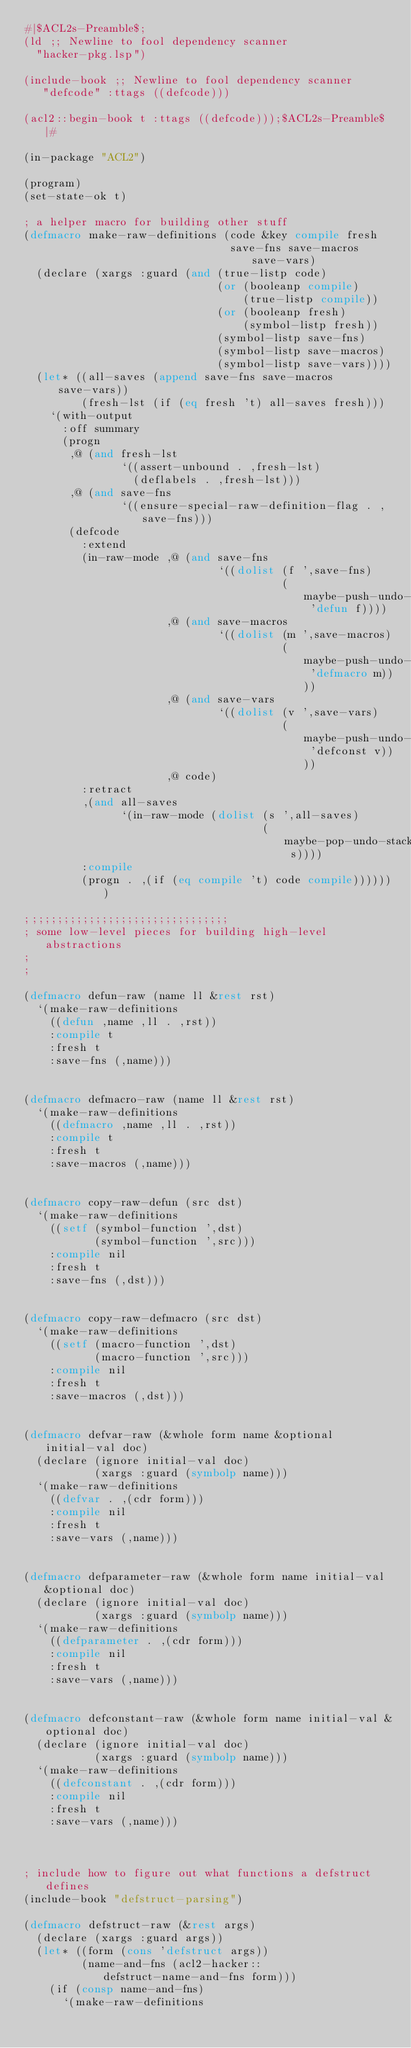<code> <loc_0><loc_0><loc_500><loc_500><_Lisp_>#|$ACL2s-Preamble$;
(ld ;; Newline to fool dependency scanner
  "hacker-pkg.lsp")

(include-book ;; Newline to fool dependency scanner
   "defcode" :ttags ((defcode)))

(acl2::begin-book t :ttags ((defcode)));$ACL2s-Preamble$|#

(in-package "ACL2")

(program)
(set-state-ok t)

; a helper macro for building other stuff
(defmacro make-raw-definitions (code &key compile fresh
                                save-fns save-macros save-vars)
  (declare (xargs :guard (and (true-listp code)
                              (or (booleanp compile)
                                  (true-listp compile))
                              (or (booleanp fresh)
                                  (symbol-listp fresh))
                              (symbol-listp save-fns)
                              (symbol-listp save-macros)
                              (symbol-listp save-vars))))
  (let* ((all-saves (append save-fns save-macros save-vars))
         (fresh-lst (if (eq fresh 't) all-saves fresh)))
    `(with-output
      :off summary
      (progn
       ,@ (and fresh-lst
               `((assert-unbound . ,fresh-lst)
                 (deflabels . ,fresh-lst)))
       ,@ (and save-fns
               `((ensure-special-raw-definition-flag . ,save-fns)))
       (defcode
         :extend
         (in-raw-mode ,@ (and save-fns
                              `((dolist (f ',save-fns)
                                        (maybe-push-undo-stack 'defun f))))
                      ,@ (and save-macros
                              `((dolist (m ',save-macros)
                                        (maybe-push-undo-stack 'defmacro m))))
                      ,@ (and save-vars
                              `((dolist (v ',save-vars)
                                        (maybe-push-undo-stack 'defconst v))))
                      ,@ code)
         :retract
         ,(and all-saves
               `(in-raw-mode (dolist (s ',all-saves)
                                     (maybe-pop-undo-stack s))))
         :compile
         (progn . ,(if (eq compile 't) code compile)))))))

;;;;;;;;;;;;;;;;;;;;;;;;;;;;;;;;
; some low-level pieces for building high-level abstractions
;
;

(defmacro defun-raw (name ll &rest rst)
  `(make-raw-definitions
    ((defun ,name ,ll . ,rst))
    :compile t
    :fresh t
    :save-fns (,name)))


(defmacro defmacro-raw (name ll &rest rst)
  `(make-raw-definitions
    ((defmacro ,name ,ll . ,rst))
    :compile t
    :fresh t
    :save-macros (,name)))


(defmacro copy-raw-defun (src dst)
  `(make-raw-definitions
    ((setf (symbol-function ',dst)
           (symbol-function ',src)))
    :compile nil
    :fresh t
    :save-fns (,dst)))


(defmacro copy-raw-defmacro (src dst)
  `(make-raw-definitions
    ((setf (macro-function ',dst)
           (macro-function ',src)))
    :compile nil
    :fresh t
    :save-macros (,dst)))


(defmacro defvar-raw (&whole form name &optional initial-val doc)
  (declare (ignore initial-val doc)
           (xargs :guard (symbolp name)))
  `(make-raw-definitions
    ((defvar . ,(cdr form)))
    :compile nil
    :fresh t
    :save-vars (,name)))


(defmacro defparameter-raw (&whole form name initial-val &optional doc)
  (declare (ignore initial-val doc)
           (xargs :guard (symbolp name)))
  `(make-raw-definitions
    ((defparameter . ,(cdr form)))
    :compile nil
    :fresh t
    :save-vars (,name)))


(defmacro defconstant-raw (&whole form name initial-val &optional doc)
  (declare (ignore initial-val doc)
           (xargs :guard (symbolp name)))
  `(make-raw-definitions
    ((defconstant . ,(cdr form)))
    :compile nil
    :fresh t
    :save-vars (,name)))



; include how to figure out what functions a defstruct defines
(include-book "defstruct-parsing")

(defmacro defstruct-raw (&rest args)
  (declare (xargs :guard args))
  (let* ((form (cons 'defstruct args))
         (name-and-fns (acl2-hacker::defstruct-name-and-fns form)))
    (if (consp name-and-fns)
      `(make-raw-definitions</code> 